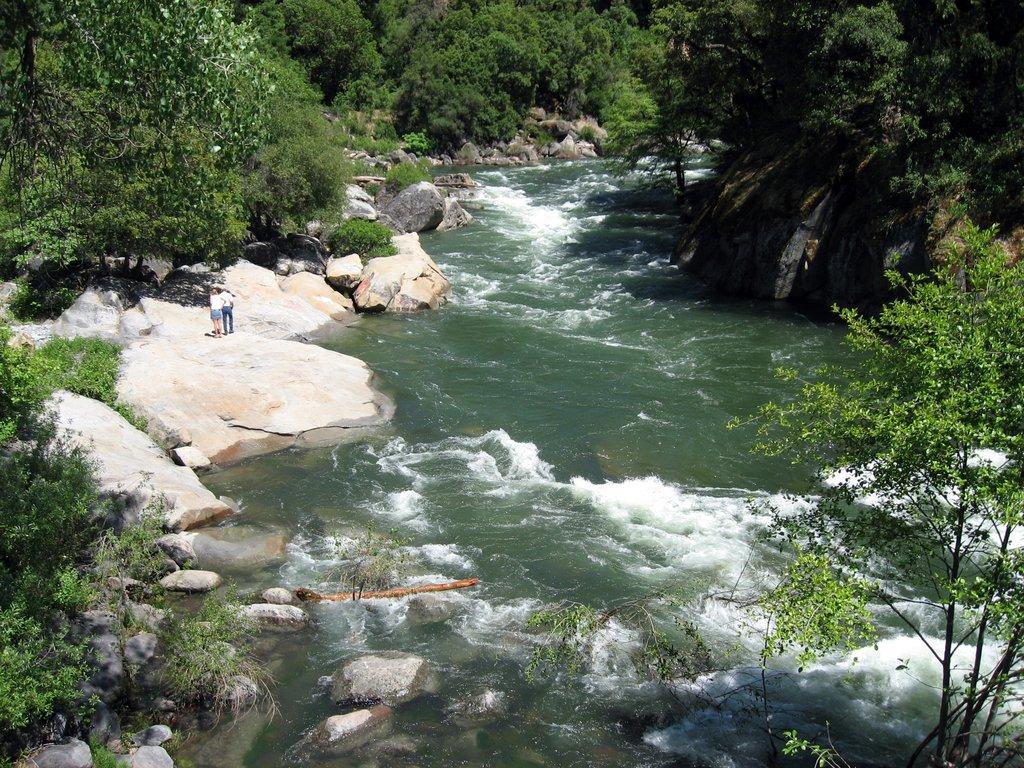How would you summarize this image in a sentence or two? This picture is clicked at a river side. On the either sides of the river there are rocks and trees. There are two people standing on a rock.  